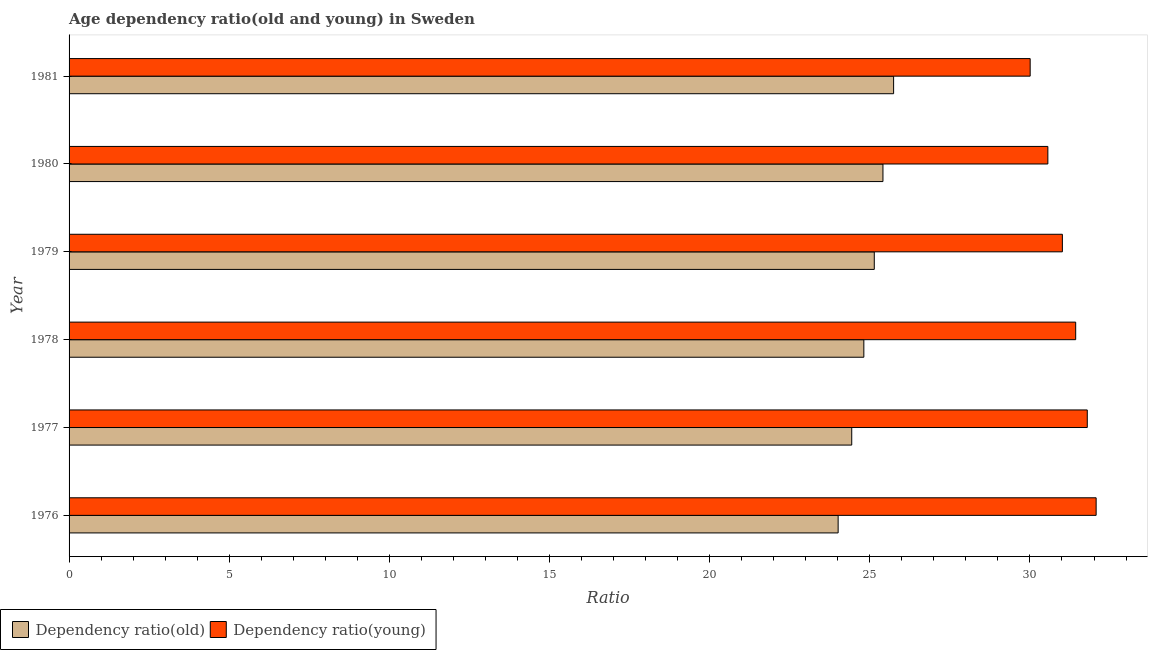How many different coloured bars are there?
Make the answer very short. 2. How many groups of bars are there?
Your response must be concise. 6. Are the number of bars per tick equal to the number of legend labels?
Give a very brief answer. Yes. What is the label of the 6th group of bars from the top?
Your response must be concise. 1976. What is the age dependency ratio(old) in 1978?
Provide a succinct answer. 24.81. Across all years, what is the maximum age dependency ratio(young)?
Make the answer very short. 32.07. Across all years, what is the minimum age dependency ratio(young)?
Keep it short and to the point. 30.01. In which year was the age dependency ratio(young) maximum?
Ensure brevity in your answer.  1976. In which year was the age dependency ratio(old) minimum?
Ensure brevity in your answer.  1976. What is the total age dependency ratio(young) in the graph?
Ensure brevity in your answer.  186.86. What is the difference between the age dependency ratio(old) in 1976 and that in 1977?
Keep it short and to the point. -0.42. What is the difference between the age dependency ratio(young) in 1976 and the age dependency ratio(old) in 1977?
Provide a short and direct response. 7.63. What is the average age dependency ratio(old) per year?
Make the answer very short. 24.93. In the year 1980, what is the difference between the age dependency ratio(old) and age dependency ratio(young)?
Provide a short and direct response. -5.15. In how many years, is the age dependency ratio(old) greater than 5 ?
Provide a succinct answer. 6. What is the ratio of the age dependency ratio(young) in 1976 to that in 1979?
Provide a short and direct response. 1.03. Is the age dependency ratio(old) in 1977 less than that in 1978?
Offer a terse response. Yes. What is the difference between the highest and the second highest age dependency ratio(old)?
Provide a short and direct response. 0.33. What is the difference between the highest and the lowest age dependency ratio(young)?
Your answer should be very brief. 2.06. In how many years, is the age dependency ratio(young) greater than the average age dependency ratio(young) taken over all years?
Keep it short and to the point. 3. Is the sum of the age dependency ratio(old) in 1977 and 1979 greater than the maximum age dependency ratio(young) across all years?
Your answer should be very brief. Yes. What does the 1st bar from the top in 1980 represents?
Keep it short and to the point. Dependency ratio(young). What does the 2nd bar from the bottom in 1981 represents?
Give a very brief answer. Dependency ratio(young). How many bars are there?
Make the answer very short. 12. Are all the bars in the graph horizontal?
Give a very brief answer. Yes. Does the graph contain any zero values?
Provide a succinct answer. No. Where does the legend appear in the graph?
Your answer should be very brief. Bottom left. How many legend labels are there?
Give a very brief answer. 2. What is the title of the graph?
Ensure brevity in your answer.  Age dependency ratio(old and young) in Sweden. Does "Young" appear as one of the legend labels in the graph?
Offer a very short reply. No. What is the label or title of the X-axis?
Offer a very short reply. Ratio. What is the label or title of the Y-axis?
Your answer should be compact. Year. What is the Ratio in Dependency ratio(old) in 1976?
Provide a succinct answer. 24.01. What is the Ratio of Dependency ratio(young) in 1976?
Your answer should be very brief. 32.07. What is the Ratio of Dependency ratio(old) in 1977?
Offer a very short reply. 24.44. What is the Ratio in Dependency ratio(young) in 1977?
Make the answer very short. 31.79. What is the Ratio in Dependency ratio(old) in 1978?
Your answer should be very brief. 24.81. What is the Ratio in Dependency ratio(young) in 1978?
Ensure brevity in your answer.  31.43. What is the Ratio in Dependency ratio(old) in 1979?
Your answer should be compact. 25.14. What is the Ratio of Dependency ratio(young) in 1979?
Offer a terse response. 31.01. What is the Ratio of Dependency ratio(old) in 1980?
Offer a terse response. 25.41. What is the Ratio in Dependency ratio(young) in 1980?
Ensure brevity in your answer.  30.56. What is the Ratio of Dependency ratio(old) in 1981?
Ensure brevity in your answer.  25.74. What is the Ratio in Dependency ratio(young) in 1981?
Keep it short and to the point. 30.01. Across all years, what is the maximum Ratio of Dependency ratio(old)?
Offer a very short reply. 25.74. Across all years, what is the maximum Ratio in Dependency ratio(young)?
Your answer should be compact. 32.07. Across all years, what is the minimum Ratio of Dependency ratio(old)?
Provide a short and direct response. 24.01. Across all years, what is the minimum Ratio in Dependency ratio(young)?
Provide a short and direct response. 30.01. What is the total Ratio in Dependency ratio(old) in the graph?
Your answer should be very brief. 149.55. What is the total Ratio in Dependency ratio(young) in the graph?
Ensure brevity in your answer.  186.86. What is the difference between the Ratio in Dependency ratio(old) in 1976 and that in 1977?
Offer a very short reply. -0.42. What is the difference between the Ratio in Dependency ratio(young) in 1976 and that in 1977?
Provide a succinct answer. 0.28. What is the difference between the Ratio in Dependency ratio(old) in 1976 and that in 1978?
Give a very brief answer. -0.8. What is the difference between the Ratio of Dependency ratio(young) in 1976 and that in 1978?
Provide a short and direct response. 0.64. What is the difference between the Ratio of Dependency ratio(old) in 1976 and that in 1979?
Give a very brief answer. -1.13. What is the difference between the Ratio in Dependency ratio(young) in 1976 and that in 1979?
Give a very brief answer. 1.05. What is the difference between the Ratio in Dependency ratio(old) in 1976 and that in 1980?
Your response must be concise. -1.4. What is the difference between the Ratio of Dependency ratio(young) in 1976 and that in 1980?
Your response must be concise. 1.51. What is the difference between the Ratio in Dependency ratio(old) in 1976 and that in 1981?
Your answer should be compact. -1.73. What is the difference between the Ratio in Dependency ratio(young) in 1976 and that in 1981?
Keep it short and to the point. 2.06. What is the difference between the Ratio in Dependency ratio(old) in 1977 and that in 1978?
Your response must be concise. -0.38. What is the difference between the Ratio in Dependency ratio(young) in 1977 and that in 1978?
Offer a very short reply. 0.36. What is the difference between the Ratio in Dependency ratio(old) in 1977 and that in 1979?
Your answer should be compact. -0.7. What is the difference between the Ratio of Dependency ratio(young) in 1977 and that in 1979?
Provide a short and direct response. 0.78. What is the difference between the Ratio in Dependency ratio(old) in 1977 and that in 1980?
Keep it short and to the point. -0.97. What is the difference between the Ratio of Dependency ratio(young) in 1977 and that in 1980?
Offer a terse response. 1.23. What is the difference between the Ratio of Dependency ratio(old) in 1977 and that in 1981?
Provide a short and direct response. -1.31. What is the difference between the Ratio of Dependency ratio(young) in 1977 and that in 1981?
Your response must be concise. 1.78. What is the difference between the Ratio in Dependency ratio(old) in 1978 and that in 1979?
Your answer should be compact. -0.33. What is the difference between the Ratio in Dependency ratio(young) in 1978 and that in 1979?
Provide a short and direct response. 0.42. What is the difference between the Ratio in Dependency ratio(old) in 1978 and that in 1980?
Your response must be concise. -0.6. What is the difference between the Ratio in Dependency ratio(young) in 1978 and that in 1980?
Your response must be concise. 0.87. What is the difference between the Ratio in Dependency ratio(old) in 1978 and that in 1981?
Provide a succinct answer. -0.93. What is the difference between the Ratio of Dependency ratio(young) in 1978 and that in 1981?
Ensure brevity in your answer.  1.42. What is the difference between the Ratio of Dependency ratio(old) in 1979 and that in 1980?
Make the answer very short. -0.27. What is the difference between the Ratio in Dependency ratio(young) in 1979 and that in 1980?
Provide a succinct answer. 0.45. What is the difference between the Ratio of Dependency ratio(old) in 1979 and that in 1981?
Provide a succinct answer. -0.6. What is the difference between the Ratio of Dependency ratio(old) in 1980 and that in 1981?
Your response must be concise. -0.33. What is the difference between the Ratio of Dependency ratio(young) in 1980 and that in 1981?
Ensure brevity in your answer.  0.55. What is the difference between the Ratio in Dependency ratio(old) in 1976 and the Ratio in Dependency ratio(young) in 1977?
Your answer should be compact. -7.78. What is the difference between the Ratio in Dependency ratio(old) in 1976 and the Ratio in Dependency ratio(young) in 1978?
Your answer should be compact. -7.42. What is the difference between the Ratio in Dependency ratio(old) in 1976 and the Ratio in Dependency ratio(young) in 1979?
Offer a terse response. -7. What is the difference between the Ratio in Dependency ratio(old) in 1976 and the Ratio in Dependency ratio(young) in 1980?
Your answer should be compact. -6.55. What is the difference between the Ratio in Dependency ratio(old) in 1976 and the Ratio in Dependency ratio(young) in 1981?
Your answer should be very brief. -6. What is the difference between the Ratio of Dependency ratio(old) in 1977 and the Ratio of Dependency ratio(young) in 1978?
Your answer should be compact. -6.99. What is the difference between the Ratio in Dependency ratio(old) in 1977 and the Ratio in Dependency ratio(young) in 1979?
Offer a terse response. -6.58. What is the difference between the Ratio of Dependency ratio(old) in 1977 and the Ratio of Dependency ratio(young) in 1980?
Ensure brevity in your answer.  -6.12. What is the difference between the Ratio of Dependency ratio(old) in 1977 and the Ratio of Dependency ratio(young) in 1981?
Your response must be concise. -5.57. What is the difference between the Ratio in Dependency ratio(old) in 1978 and the Ratio in Dependency ratio(young) in 1979?
Provide a succinct answer. -6.2. What is the difference between the Ratio in Dependency ratio(old) in 1978 and the Ratio in Dependency ratio(young) in 1980?
Offer a very short reply. -5.74. What is the difference between the Ratio in Dependency ratio(old) in 1978 and the Ratio in Dependency ratio(young) in 1981?
Provide a succinct answer. -5.19. What is the difference between the Ratio of Dependency ratio(old) in 1979 and the Ratio of Dependency ratio(young) in 1980?
Give a very brief answer. -5.42. What is the difference between the Ratio of Dependency ratio(old) in 1979 and the Ratio of Dependency ratio(young) in 1981?
Your answer should be very brief. -4.87. What is the difference between the Ratio in Dependency ratio(old) in 1980 and the Ratio in Dependency ratio(young) in 1981?
Offer a very short reply. -4.6. What is the average Ratio of Dependency ratio(old) per year?
Your answer should be compact. 24.93. What is the average Ratio of Dependency ratio(young) per year?
Provide a succinct answer. 31.14. In the year 1976, what is the difference between the Ratio of Dependency ratio(old) and Ratio of Dependency ratio(young)?
Your response must be concise. -8.06. In the year 1977, what is the difference between the Ratio of Dependency ratio(old) and Ratio of Dependency ratio(young)?
Keep it short and to the point. -7.35. In the year 1978, what is the difference between the Ratio in Dependency ratio(old) and Ratio in Dependency ratio(young)?
Your response must be concise. -6.61. In the year 1979, what is the difference between the Ratio of Dependency ratio(old) and Ratio of Dependency ratio(young)?
Give a very brief answer. -5.87. In the year 1980, what is the difference between the Ratio of Dependency ratio(old) and Ratio of Dependency ratio(young)?
Keep it short and to the point. -5.15. In the year 1981, what is the difference between the Ratio in Dependency ratio(old) and Ratio in Dependency ratio(young)?
Offer a terse response. -4.26. What is the ratio of the Ratio in Dependency ratio(old) in 1976 to that in 1977?
Make the answer very short. 0.98. What is the ratio of the Ratio in Dependency ratio(young) in 1976 to that in 1977?
Give a very brief answer. 1.01. What is the ratio of the Ratio of Dependency ratio(old) in 1976 to that in 1978?
Keep it short and to the point. 0.97. What is the ratio of the Ratio in Dependency ratio(young) in 1976 to that in 1978?
Offer a terse response. 1.02. What is the ratio of the Ratio in Dependency ratio(old) in 1976 to that in 1979?
Keep it short and to the point. 0.96. What is the ratio of the Ratio of Dependency ratio(young) in 1976 to that in 1979?
Offer a very short reply. 1.03. What is the ratio of the Ratio in Dependency ratio(old) in 1976 to that in 1980?
Ensure brevity in your answer.  0.94. What is the ratio of the Ratio of Dependency ratio(young) in 1976 to that in 1980?
Your response must be concise. 1.05. What is the ratio of the Ratio in Dependency ratio(old) in 1976 to that in 1981?
Provide a succinct answer. 0.93. What is the ratio of the Ratio in Dependency ratio(young) in 1976 to that in 1981?
Give a very brief answer. 1.07. What is the ratio of the Ratio of Dependency ratio(young) in 1977 to that in 1978?
Ensure brevity in your answer.  1.01. What is the ratio of the Ratio in Dependency ratio(old) in 1977 to that in 1979?
Offer a terse response. 0.97. What is the ratio of the Ratio of Dependency ratio(young) in 1977 to that in 1979?
Offer a very short reply. 1.03. What is the ratio of the Ratio of Dependency ratio(old) in 1977 to that in 1980?
Your answer should be compact. 0.96. What is the ratio of the Ratio in Dependency ratio(young) in 1977 to that in 1980?
Offer a very short reply. 1.04. What is the ratio of the Ratio of Dependency ratio(old) in 1977 to that in 1981?
Offer a terse response. 0.95. What is the ratio of the Ratio of Dependency ratio(young) in 1977 to that in 1981?
Provide a short and direct response. 1.06. What is the ratio of the Ratio of Dependency ratio(old) in 1978 to that in 1979?
Your answer should be compact. 0.99. What is the ratio of the Ratio in Dependency ratio(young) in 1978 to that in 1979?
Your response must be concise. 1.01. What is the ratio of the Ratio in Dependency ratio(old) in 1978 to that in 1980?
Provide a succinct answer. 0.98. What is the ratio of the Ratio of Dependency ratio(young) in 1978 to that in 1980?
Offer a terse response. 1.03. What is the ratio of the Ratio in Dependency ratio(old) in 1978 to that in 1981?
Ensure brevity in your answer.  0.96. What is the ratio of the Ratio of Dependency ratio(young) in 1978 to that in 1981?
Offer a terse response. 1.05. What is the ratio of the Ratio of Dependency ratio(old) in 1979 to that in 1980?
Your answer should be compact. 0.99. What is the ratio of the Ratio of Dependency ratio(young) in 1979 to that in 1980?
Your answer should be very brief. 1.01. What is the ratio of the Ratio in Dependency ratio(old) in 1979 to that in 1981?
Make the answer very short. 0.98. What is the ratio of the Ratio in Dependency ratio(young) in 1979 to that in 1981?
Provide a succinct answer. 1.03. What is the ratio of the Ratio of Dependency ratio(old) in 1980 to that in 1981?
Your response must be concise. 0.99. What is the ratio of the Ratio of Dependency ratio(young) in 1980 to that in 1981?
Offer a terse response. 1.02. What is the difference between the highest and the second highest Ratio in Dependency ratio(old)?
Provide a short and direct response. 0.33. What is the difference between the highest and the second highest Ratio of Dependency ratio(young)?
Ensure brevity in your answer.  0.28. What is the difference between the highest and the lowest Ratio of Dependency ratio(old)?
Give a very brief answer. 1.73. What is the difference between the highest and the lowest Ratio in Dependency ratio(young)?
Your response must be concise. 2.06. 